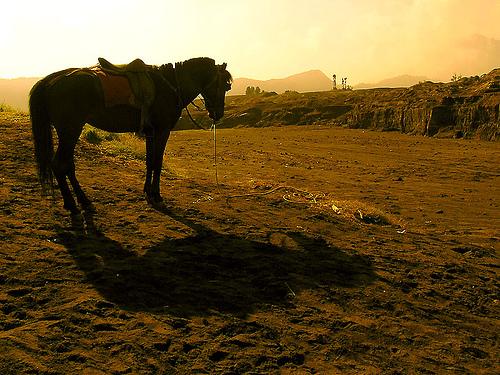What continent is this in?
Quick response, please. North america. Is the sun in front of or behind the horse?
Quick response, please. Behind. Is this a desert?
Concise answer only. Yes. Is the horse saddled?
Keep it brief. Yes. Is the water in the image?
Keep it brief. No. Is he making tracks?
Concise answer only. No. How many horses are pictured?
Quick response, please. 1. What mammal is this?
Short answer required. Horse. What color is the horse?
Concise answer only. Brown. What leather object would you sit on if you rode this horse?
Short answer required. Saddle. What side of the horse is the shadow?
Give a very brief answer. Right. Is this a cow or a horse?
Quick response, please. Horse. What animal is this?
Quick response, please. Horse. Where is the horse?
Give a very brief answer. Field. What kind of animal is in this picture?
Answer briefly. Horse. 